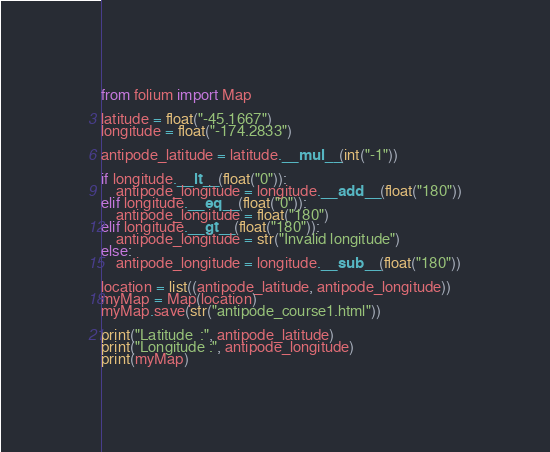<code> <loc_0><loc_0><loc_500><loc_500><_Python_>from folium import Map

latitude = float("-45.1667")
longitude = float("-174.2833")

antipode_latitude = latitude.__mul__(int("-1"))

if longitude.__lt__(float("0")):
    antipode_longitude = longitude.__add__(float("180"))
elif longitude.__eq__(float("0")):
    antipode_longitude = float("180")
elif longitude.__gt__(float("180")):
    antipode_longitude = str("Invalid longitude")
else:
    antipode_longitude = longitude.__sub__(float("180"))

location = list((antipode_latitude, antipode_longitude))
myMap = Map(location)
myMap.save(str("antipode_course1.html"))

print("Latitude  :", antipode_latitude)
print("Longitude :", antipode_longitude)
print(myMap)</code> 